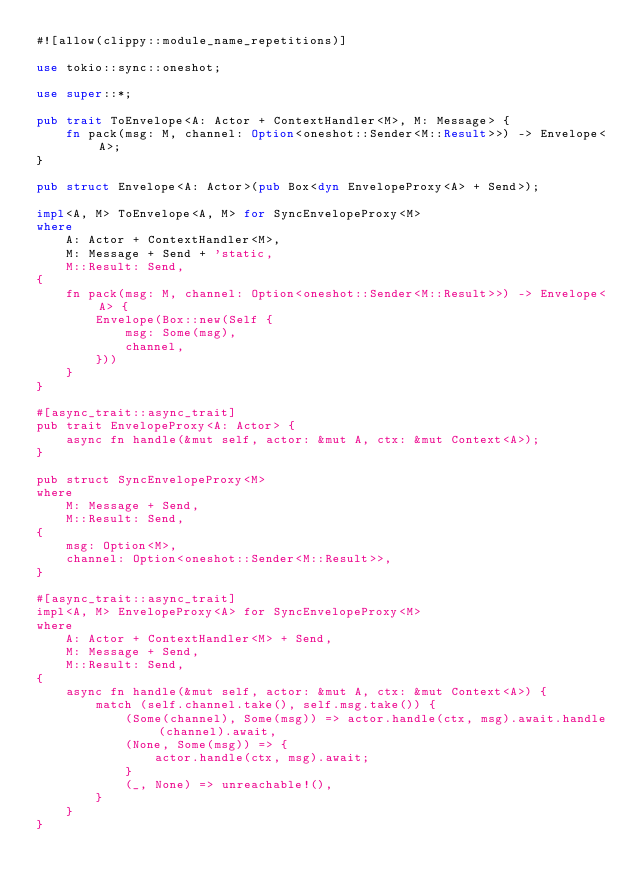Convert code to text. <code><loc_0><loc_0><loc_500><loc_500><_Rust_>#![allow(clippy::module_name_repetitions)]

use tokio::sync::oneshot;

use super::*;

pub trait ToEnvelope<A: Actor + ContextHandler<M>, M: Message> {
    fn pack(msg: M, channel: Option<oneshot::Sender<M::Result>>) -> Envelope<A>;
}

pub struct Envelope<A: Actor>(pub Box<dyn EnvelopeProxy<A> + Send>);

impl<A, M> ToEnvelope<A, M> for SyncEnvelopeProxy<M>
where
    A: Actor + ContextHandler<M>,
    M: Message + Send + 'static,
    M::Result: Send,
{
    fn pack(msg: M, channel: Option<oneshot::Sender<M::Result>>) -> Envelope<A> {
        Envelope(Box::new(Self {
            msg: Some(msg),
            channel,
        }))
    }
}

#[async_trait::async_trait]
pub trait EnvelopeProxy<A: Actor> {
    async fn handle(&mut self, actor: &mut A, ctx: &mut Context<A>);
}

pub struct SyncEnvelopeProxy<M>
where
    M: Message + Send,
    M::Result: Send,
{
    msg: Option<M>,
    channel: Option<oneshot::Sender<M::Result>>,
}

#[async_trait::async_trait]
impl<A, M> EnvelopeProxy<A> for SyncEnvelopeProxy<M>
where
    A: Actor + ContextHandler<M> + Send,
    M: Message + Send,
    M::Result: Send,
{
    async fn handle(&mut self, actor: &mut A, ctx: &mut Context<A>) {
        match (self.channel.take(), self.msg.take()) {
            (Some(channel), Some(msg)) => actor.handle(ctx, msg).await.handle(channel).await,
            (None, Some(msg)) => {
                actor.handle(ctx, msg).await;
            }
            (_, None) => unreachable!(),
        }
    }
}
</code> 